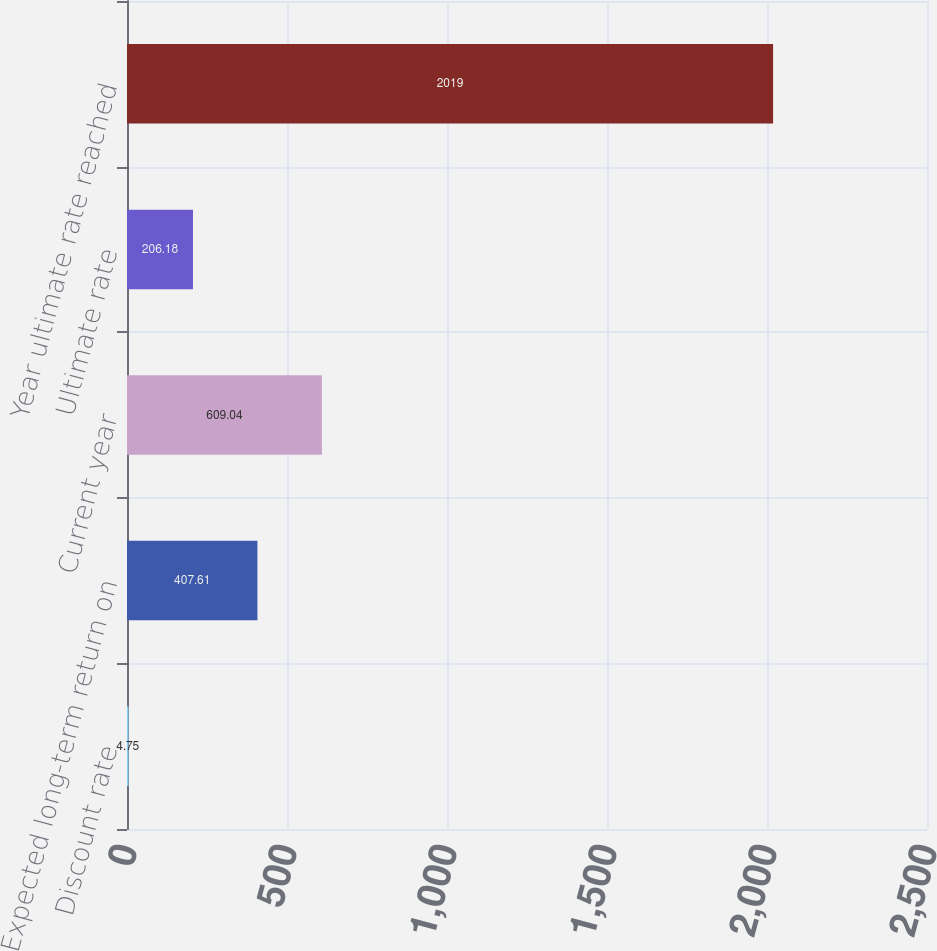Convert chart. <chart><loc_0><loc_0><loc_500><loc_500><bar_chart><fcel>Discount rate<fcel>Expected long-term return on<fcel>Current year<fcel>Ultimate rate<fcel>Year ultimate rate reached<nl><fcel>4.75<fcel>407.61<fcel>609.04<fcel>206.18<fcel>2019<nl></chart> 